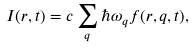<formula> <loc_0><loc_0><loc_500><loc_500>I ( { r } , t ) = c \sum _ { q } \hbar { \omega } _ { q } f ( { r } , { q } , t ) ,</formula> 